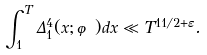Convert formula to latex. <formula><loc_0><loc_0><loc_500><loc_500>\int _ { 1 } ^ { T } \Delta _ { 1 } ^ { 4 } ( x ; \varphi ) d x \ll T ^ { 1 1 / 2 + \varepsilon } .</formula> 